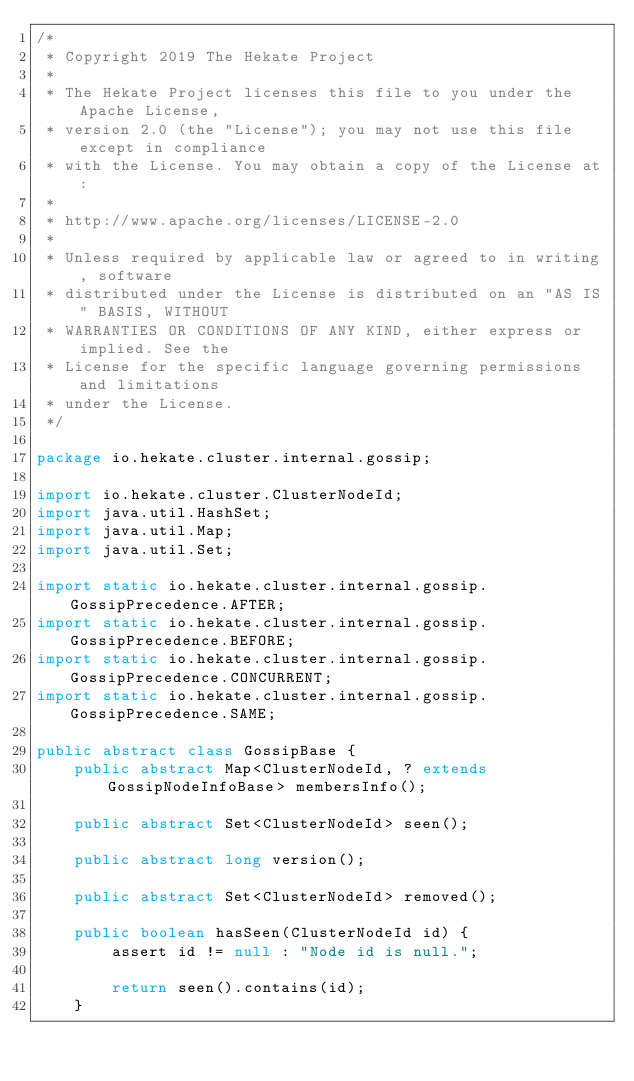Convert code to text. <code><loc_0><loc_0><loc_500><loc_500><_Java_>/*
 * Copyright 2019 The Hekate Project
 *
 * The Hekate Project licenses this file to you under the Apache License,
 * version 2.0 (the "License"); you may not use this file except in compliance
 * with the License. You may obtain a copy of the License at:
 *
 * http://www.apache.org/licenses/LICENSE-2.0
 *
 * Unless required by applicable law or agreed to in writing, software
 * distributed under the License is distributed on an "AS IS" BASIS, WITHOUT
 * WARRANTIES OR CONDITIONS OF ANY KIND, either express or implied. See the
 * License for the specific language governing permissions and limitations
 * under the License.
 */

package io.hekate.cluster.internal.gossip;

import io.hekate.cluster.ClusterNodeId;
import java.util.HashSet;
import java.util.Map;
import java.util.Set;

import static io.hekate.cluster.internal.gossip.GossipPrecedence.AFTER;
import static io.hekate.cluster.internal.gossip.GossipPrecedence.BEFORE;
import static io.hekate.cluster.internal.gossip.GossipPrecedence.CONCURRENT;
import static io.hekate.cluster.internal.gossip.GossipPrecedence.SAME;

public abstract class GossipBase {
    public abstract Map<ClusterNodeId, ? extends GossipNodeInfoBase> membersInfo();

    public abstract Set<ClusterNodeId> seen();

    public abstract long version();

    public abstract Set<ClusterNodeId> removed();

    public boolean hasSeen(ClusterNodeId id) {
        assert id != null : "Node id is null.";

        return seen().contains(id);
    }
</code> 